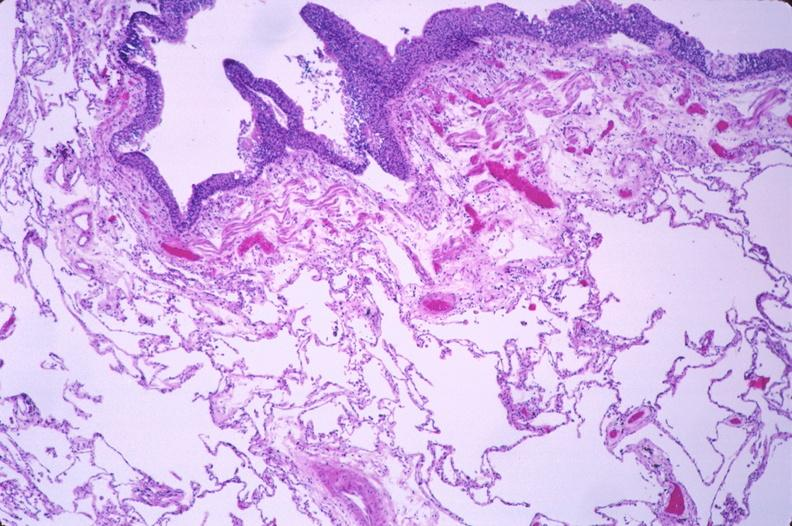s previous slide from this case present?
Answer the question using a single word or phrase. No 